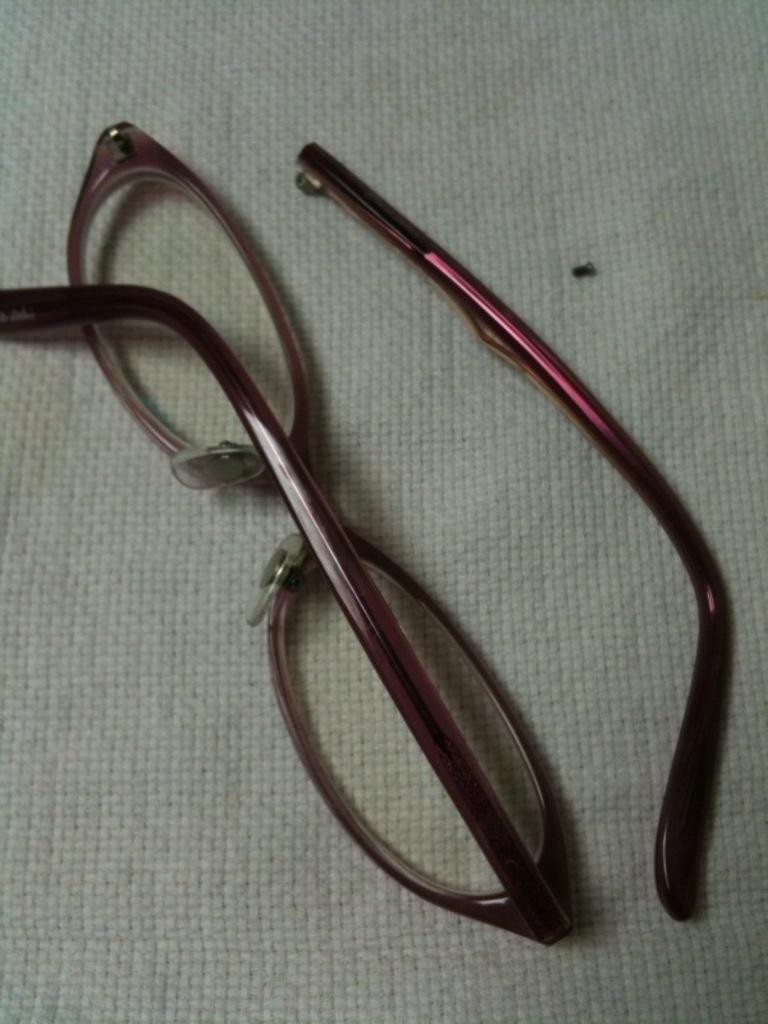What is the main subject of the image? The main subject of the image is a broken pair of spectacles. Can you describe the condition of the spectacles? One leg of the spectacles is on a white cloth. What type of education is being offered by the spectacles in the image? The spectacles in the image are broken and cannot offer any education. 